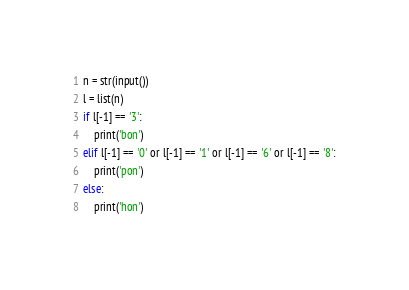Convert code to text. <code><loc_0><loc_0><loc_500><loc_500><_Python_>n = str(input())
l = list(n)
if l[-1] == '3':
    print('bon')
elif l[-1] == '0' or l[-1] == '1' or l[-1] == '6' or l[-1] == '8':
    print('pon')
else:
    print('hon')</code> 